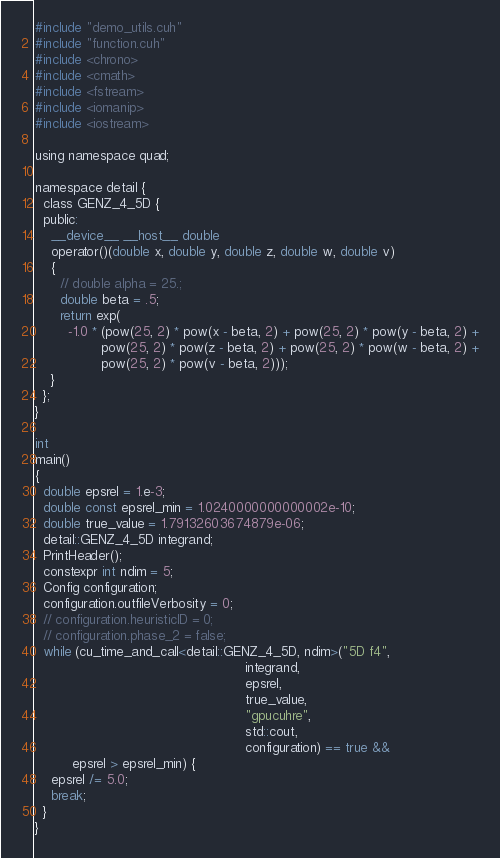Convert code to text. <code><loc_0><loc_0><loc_500><loc_500><_Cuda_>#include "demo_utils.cuh"
#include "function.cuh"
#include <chrono>
#include <cmath>
#include <fstream>
#include <iomanip>
#include <iostream>

using namespace quad;

namespace detail {
  class GENZ_4_5D {
  public:
    __device__ __host__ double
    operator()(double x, double y, double z, double w, double v)
    {
      // double alpha = 25.;
      double beta = .5;
      return exp(
        -1.0 * (pow(25, 2) * pow(x - beta, 2) + pow(25, 2) * pow(y - beta, 2) +
                pow(25, 2) * pow(z - beta, 2) + pow(25, 2) * pow(w - beta, 2) +
                pow(25, 2) * pow(v - beta, 2)));
    }
  };
}

int
main()
{
  double epsrel = 1.e-3;
  double const epsrel_min = 1.0240000000000002e-10;
  double true_value = 1.79132603674879e-06;
  detail::GENZ_4_5D integrand;
  PrintHeader();
  constexpr int ndim = 5;
  Config configuration;
  configuration.outfileVerbosity = 0;
  // configuration.heuristicID = 0;
  // configuration.phase_2 = false;
  while (cu_time_and_call<detail::GENZ_4_5D, ndim>("5D f4",
                                                   integrand,
                                                   epsrel,
                                                   true_value,
                                                   "gpucuhre",
                                                   std::cout,
                                                   configuration) == true &&
         epsrel > epsrel_min) {
    epsrel /= 5.0;
    break;
  }
}
</code> 